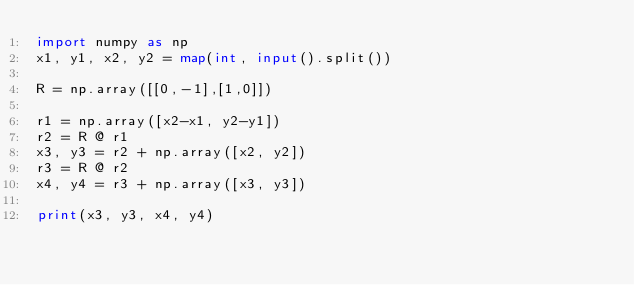<code> <loc_0><loc_0><loc_500><loc_500><_Python_>import numpy as np
x1, y1, x2, y2 = map(int, input().split())

R = np.array([[0,-1],[1,0]])

r1 = np.array([x2-x1, y2-y1])
r2 = R @ r1
x3, y3 = r2 + np.array([x2, y2])
r3 = R @ r2
x4, y4 = r3 + np.array([x3, y3])

print(x3, y3, x4, y4)</code> 